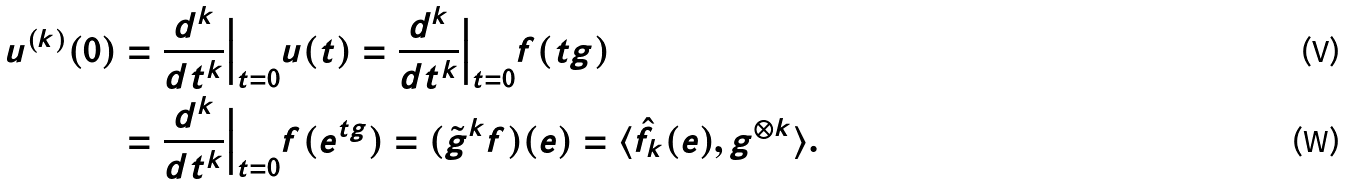Convert formula to latex. <formula><loc_0><loc_0><loc_500><loc_500>u ^ { ( k ) } ( 0 ) & = \frac { d ^ { k } } { d t ^ { k } } \Big | _ { t = 0 } u ( t ) = \frac { d ^ { k } } { d t ^ { k } } \Big | _ { t = 0 } f ( t g ) \\ & = \frac { d ^ { k } } { d t ^ { k } } \Big | _ { t = 0 } f ( e ^ { t g } ) = ( \tilde { g } ^ { k } f ) ( e ) = \langle \hat { f } _ { k } ( e ) , g ^ { \otimes k } \rangle .</formula> 